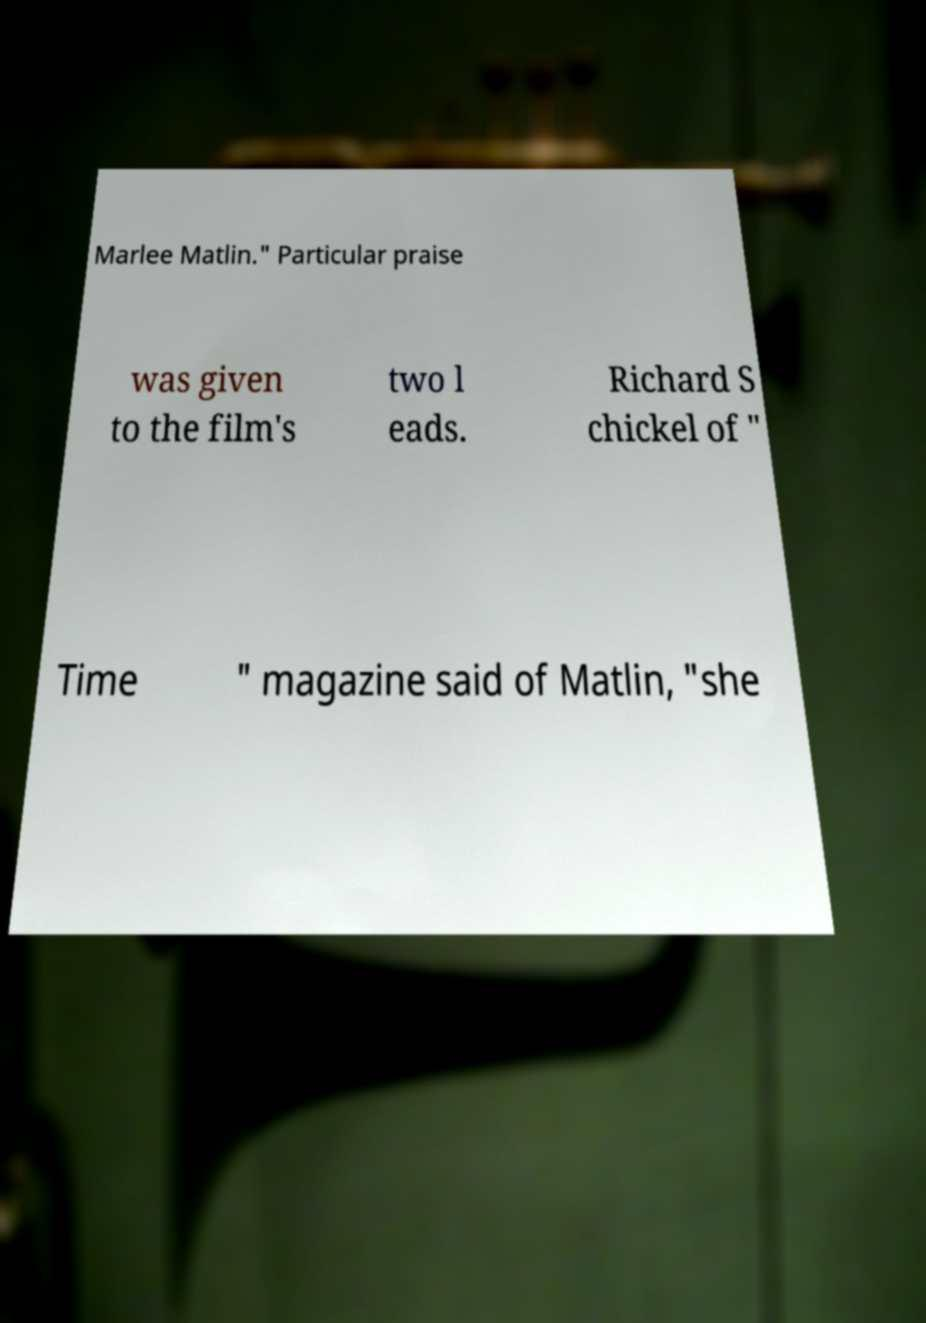Can you read and provide the text displayed in the image?This photo seems to have some interesting text. Can you extract and type it out for me? Marlee Matlin." Particular praise was given to the film's two l eads. Richard S chickel of " Time " magazine said of Matlin, "she 